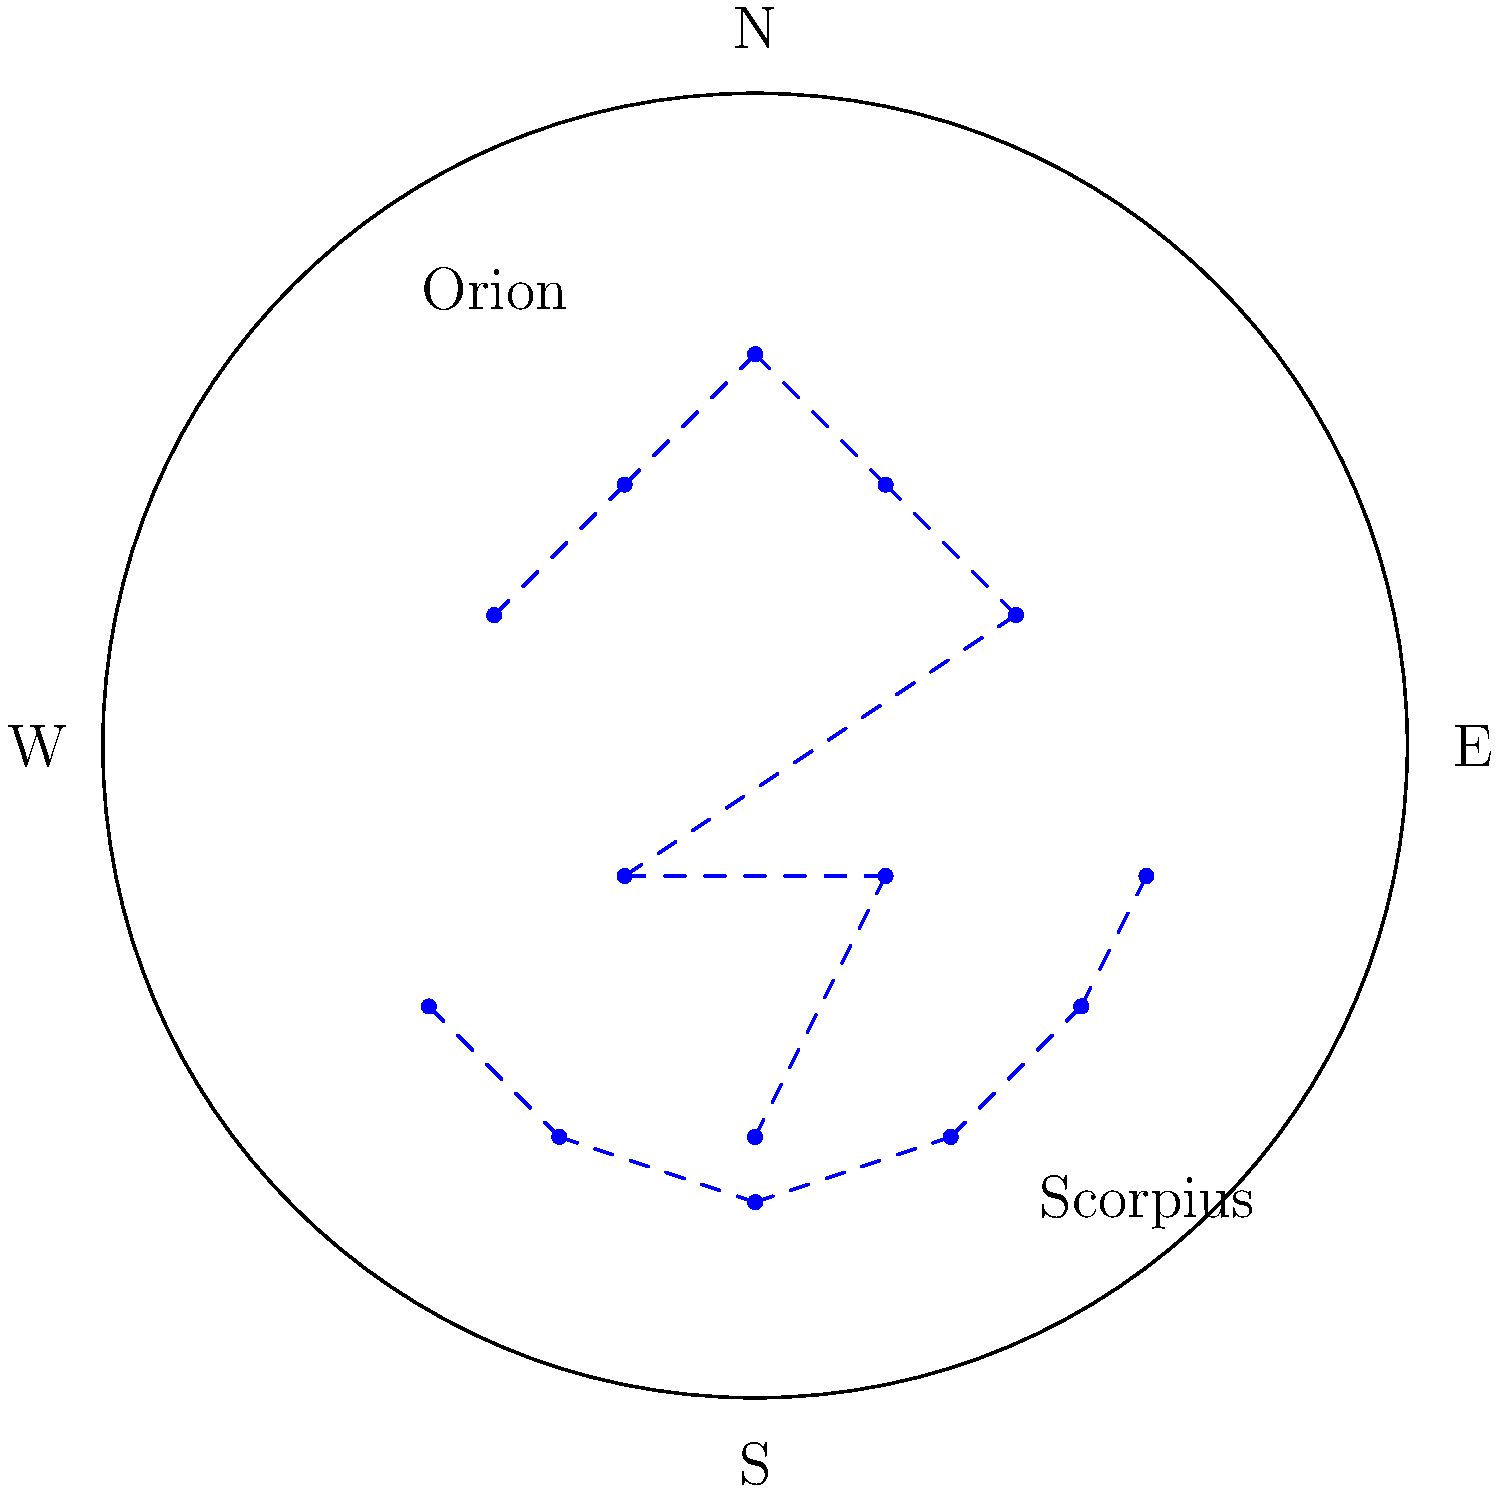During which farming season would you be more likely to see the constellation Orion prominently in the night sky: planting season (spring) or harvest season (autumn)? To answer this question, we need to consider the following steps:

1. Understand the visibility of constellations:
   - Constellations appear to move across the sky due to Earth's rotation and orbit around the Sun.
   - Different constellations are visible during different seasons.

2. Orion's visibility:
   - Orion is most visible in the winter night sky in the Northern Hemisphere.
   - It begins to rise in the east in late autumn and is prominent throughout winter.
   - By late spring, Orion is no longer visible in the night sky.

3. Farming seasons:
   - Planting season typically occurs in spring (March to May).
   - Harvest season usually takes place in autumn (September to November).

4. Comparing Orion's visibility to farming seasons:
   - During planting season (spring), Orion is setting earlier in the evening and becoming less visible.
   - During harvest season (autumn), Orion is beginning to rise in the east and becoming more prominent.

5. Conclusion:
   - Orion is more likely to be seen prominently during the harvest season (autumn) as it rises in the east and becomes a dominant feature of the winter night sky.
Answer: Harvest season (autumn) 